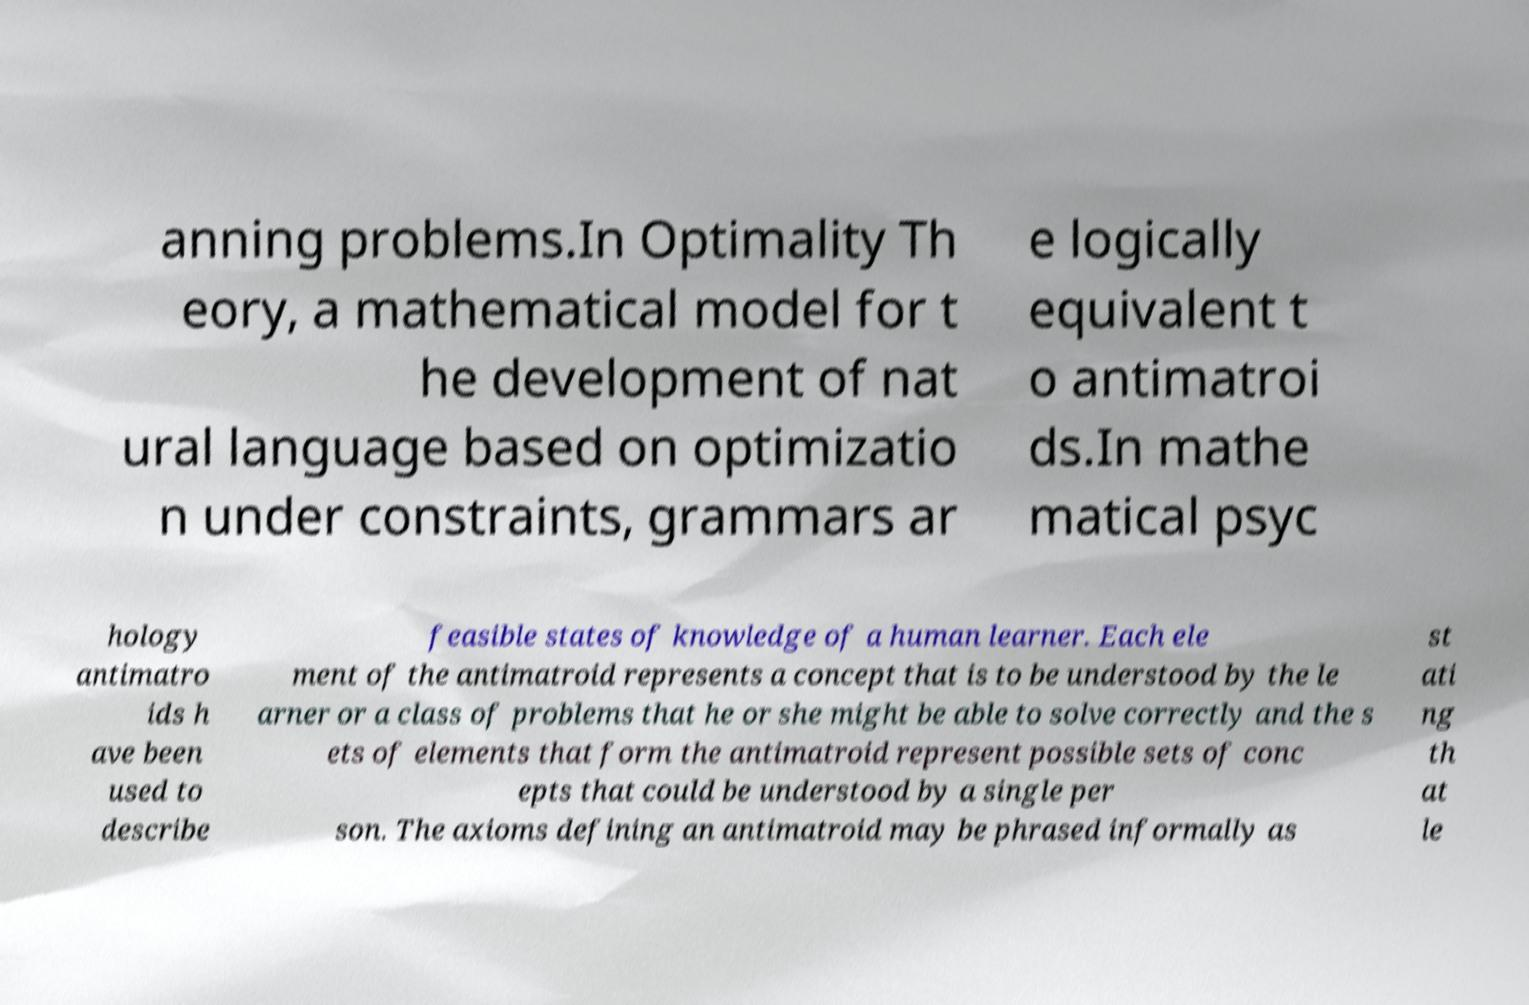There's text embedded in this image that I need extracted. Can you transcribe it verbatim? anning problems.In Optimality Th eory, a mathematical model for t he development of nat ural language based on optimizatio n under constraints, grammars ar e logically equivalent t o antimatroi ds.In mathe matical psyc hology antimatro ids h ave been used to describe feasible states of knowledge of a human learner. Each ele ment of the antimatroid represents a concept that is to be understood by the le arner or a class of problems that he or she might be able to solve correctly and the s ets of elements that form the antimatroid represent possible sets of conc epts that could be understood by a single per son. The axioms defining an antimatroid may be phrased informally as st ati ng th at le 